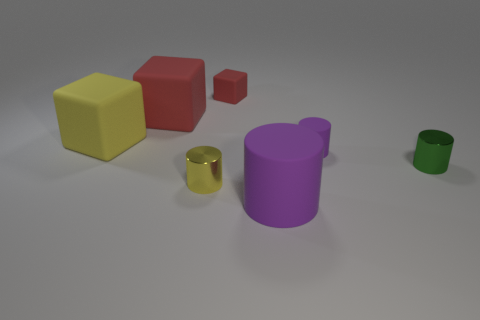Subtract all green cylinders. How many cylinders are left? 3 Add 2 small blue blocks. How many objects exist? 9 Subtract all red blocks. How many blocks are left? 1 Subtract all red balls. How many purple cylinders are left? 2 Subtract all blocks. How many objects are left? 4 Subtract 2 cylinders. How many cylinders are left? 2 Subtract all purple cubes. Subtract all purple cylinders. How many cubes are left? 3 Subtract all yellow cylinders. Subtract all cyan rubber cylinders. How many objects are left? 6 Add 3 small blocks. How many small blocks are left? 4 Add 7 tiny green matte objects. How many tiny green matte objects exist? 7 